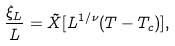<formula> <loc_0><loc_0><loc_500><loc_500>\frac { \xi _ { L } } { L } = \tilde { X } [ L ^ { 1 / \nu } ( T - T _ { c } ) ] ,</formula> 